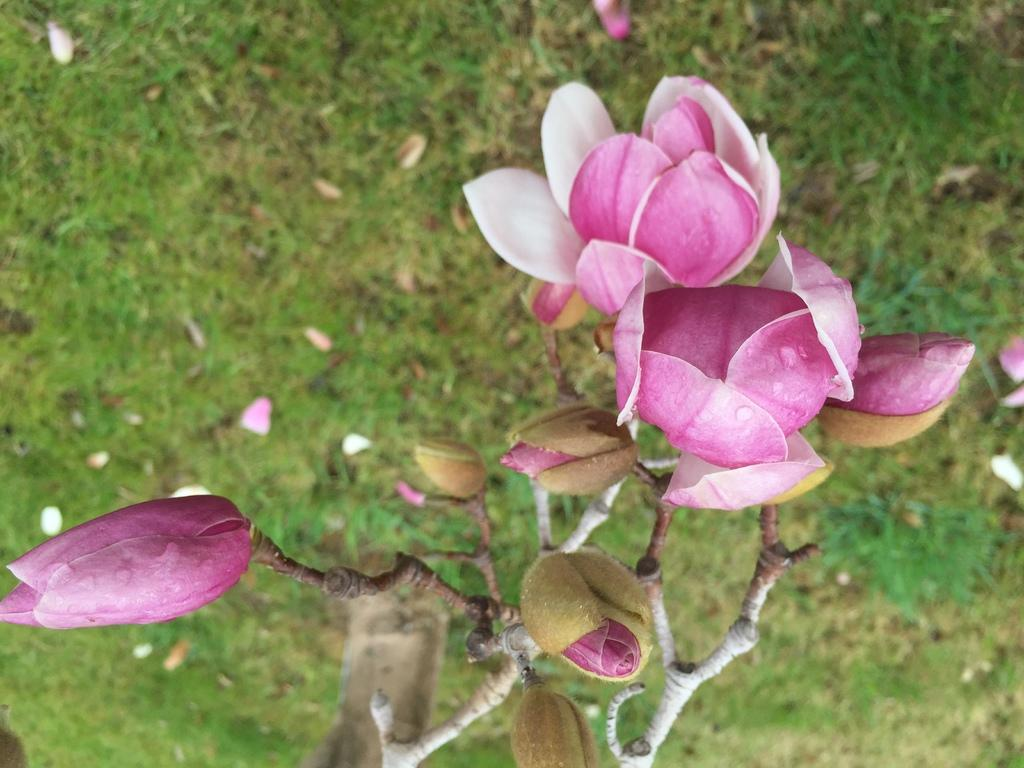What type of vegetation is present in the image? There is grass and a plant in the image. Are there any flowers visible in the image? Yes, there are pink color flowers in the image. What type of bears can be seen playing near the church in the image? There are no bears or churches present in the image; it features grass, a plant, and pink color flowers. 